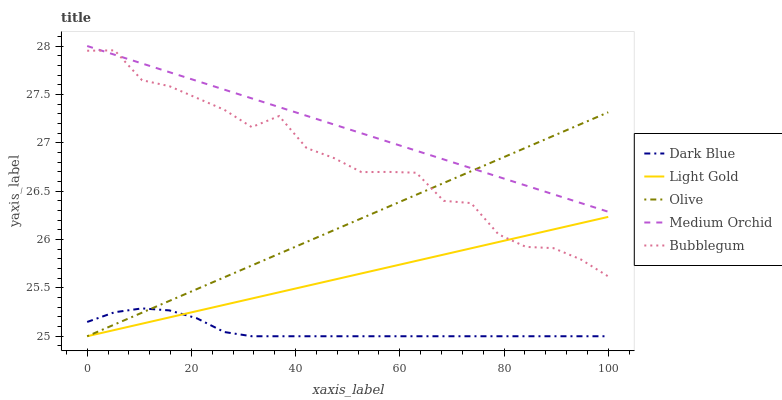Does Dark Blue have the minimum area under the curve?
Answer yes or no. Yes. Does Medium Orchid have the maximum area under the curve?
Answer yes or no. Yes. Does Medium Orchid have the minimum area under the curve?
Answer yes or no. No. Does Dark Blue have the maximum area under the curve?
Answer yes or no. No. Is Light Gold the smoothest?
Answer yes or no. Yes. Is Bubblegum the roughest?
Answer yes or no. Yes. Is Dark Blue the smoothest?
Answer yes or no. No. Is Dark Blue the roughest?
Answer yes or no. No. Does Olive have the lowest value?
Answer yes or no. Yes. Does Medium Orchid have the lowest value?
Answer yes or no. No. Does Medium Orchid have the highest value?
Answer yes or no. Yes. Does Dark Blue have the highest value?
Answer yes or no. No. Is Dark Blue less than Medium Orchid?
Answer yes or no. Yes. Is Medium Orchid greater than Dark Blue?
Answer yes or no. Yes. Does Dark Blue intersect Light Gold?
Answer yes or no. Yes. Is Dark Blue less than Light Gold?
Answer yes or no. No. Is Dark Blue greater than Light Gold?
Answer yes or no. No. Does Dark Blue intersect Medium Orchid?
Answer yes or no. No. 